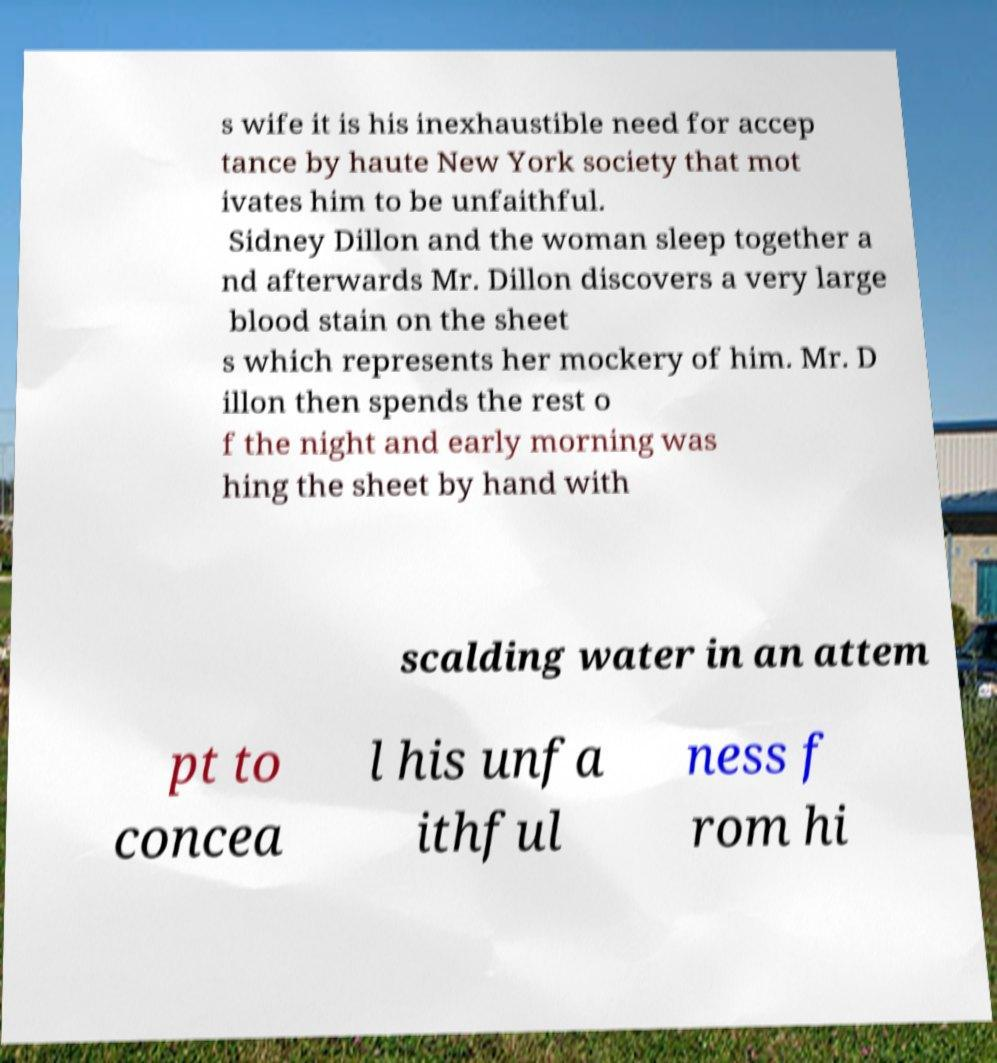I need the written content from this picture converted into text. Can you do that? s wife it is his inexhaustible need for accep tance by haute New York society that mot ivates him to be unfaithful. Sidney Dillon and the woman sleep together a nd afterwards Mr. Dillon discovers a very large blood stain on the sheet s which represents her mockery of him. Mr. D illon then spends the rest o f the night and early morning was hing the sheet by hand with scalding water in an attem pt to concea l his unfa ithful ness f rom hi 